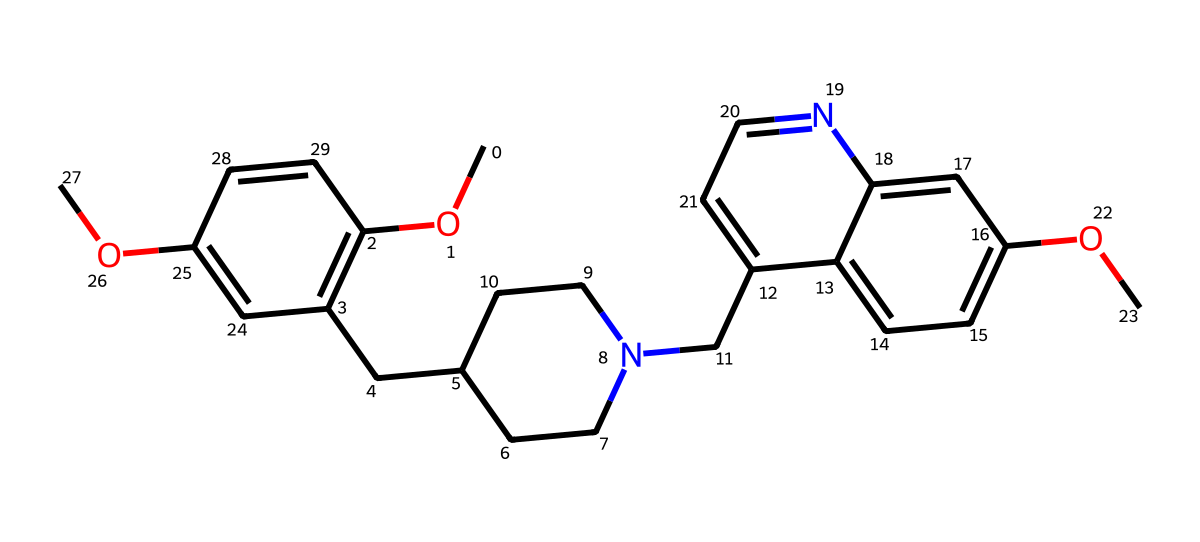What is the main functional group present in donepezil? The main functional group in donepezil is an ether, which can be identified by the presence of the -O- atom connecting two carbon groups (the methoxy groups in the structure).
Answer: ether How many hydrogen atoms are in the molecular structure of donepezil? By analyzing the SMILES representation, we count the hydrogen atoms based on connectivity, noting that each carbon usually forms four bonds; the total count eventually deduces to 22.
Answer: 22 What is the total number of rings present in the molecular structure of donepezil? The structure can be visually interpreted or by observing the SMILES notation, showing three distinct rings connected to the primary structure, resulting in a total of three rings.
Answer: 3 Does donepezil contain any nitrogen atoms in its structure? Yes, donepezil contains nitrogen atoms, which can be identified from the SMILES where 'N' appears, specifically noting its role in the amine functionality that affects its medicinal properties.
Answer: yes What type of compound is donepezil classified as? Donepezil is classified as a pharmaceutical or medicinal compound, specifically an acetylcholinesterase inhibitor, as inferred from its functional groups and chemical actions primarily involved in neurological treatments.
Answer: pharmaceutical 